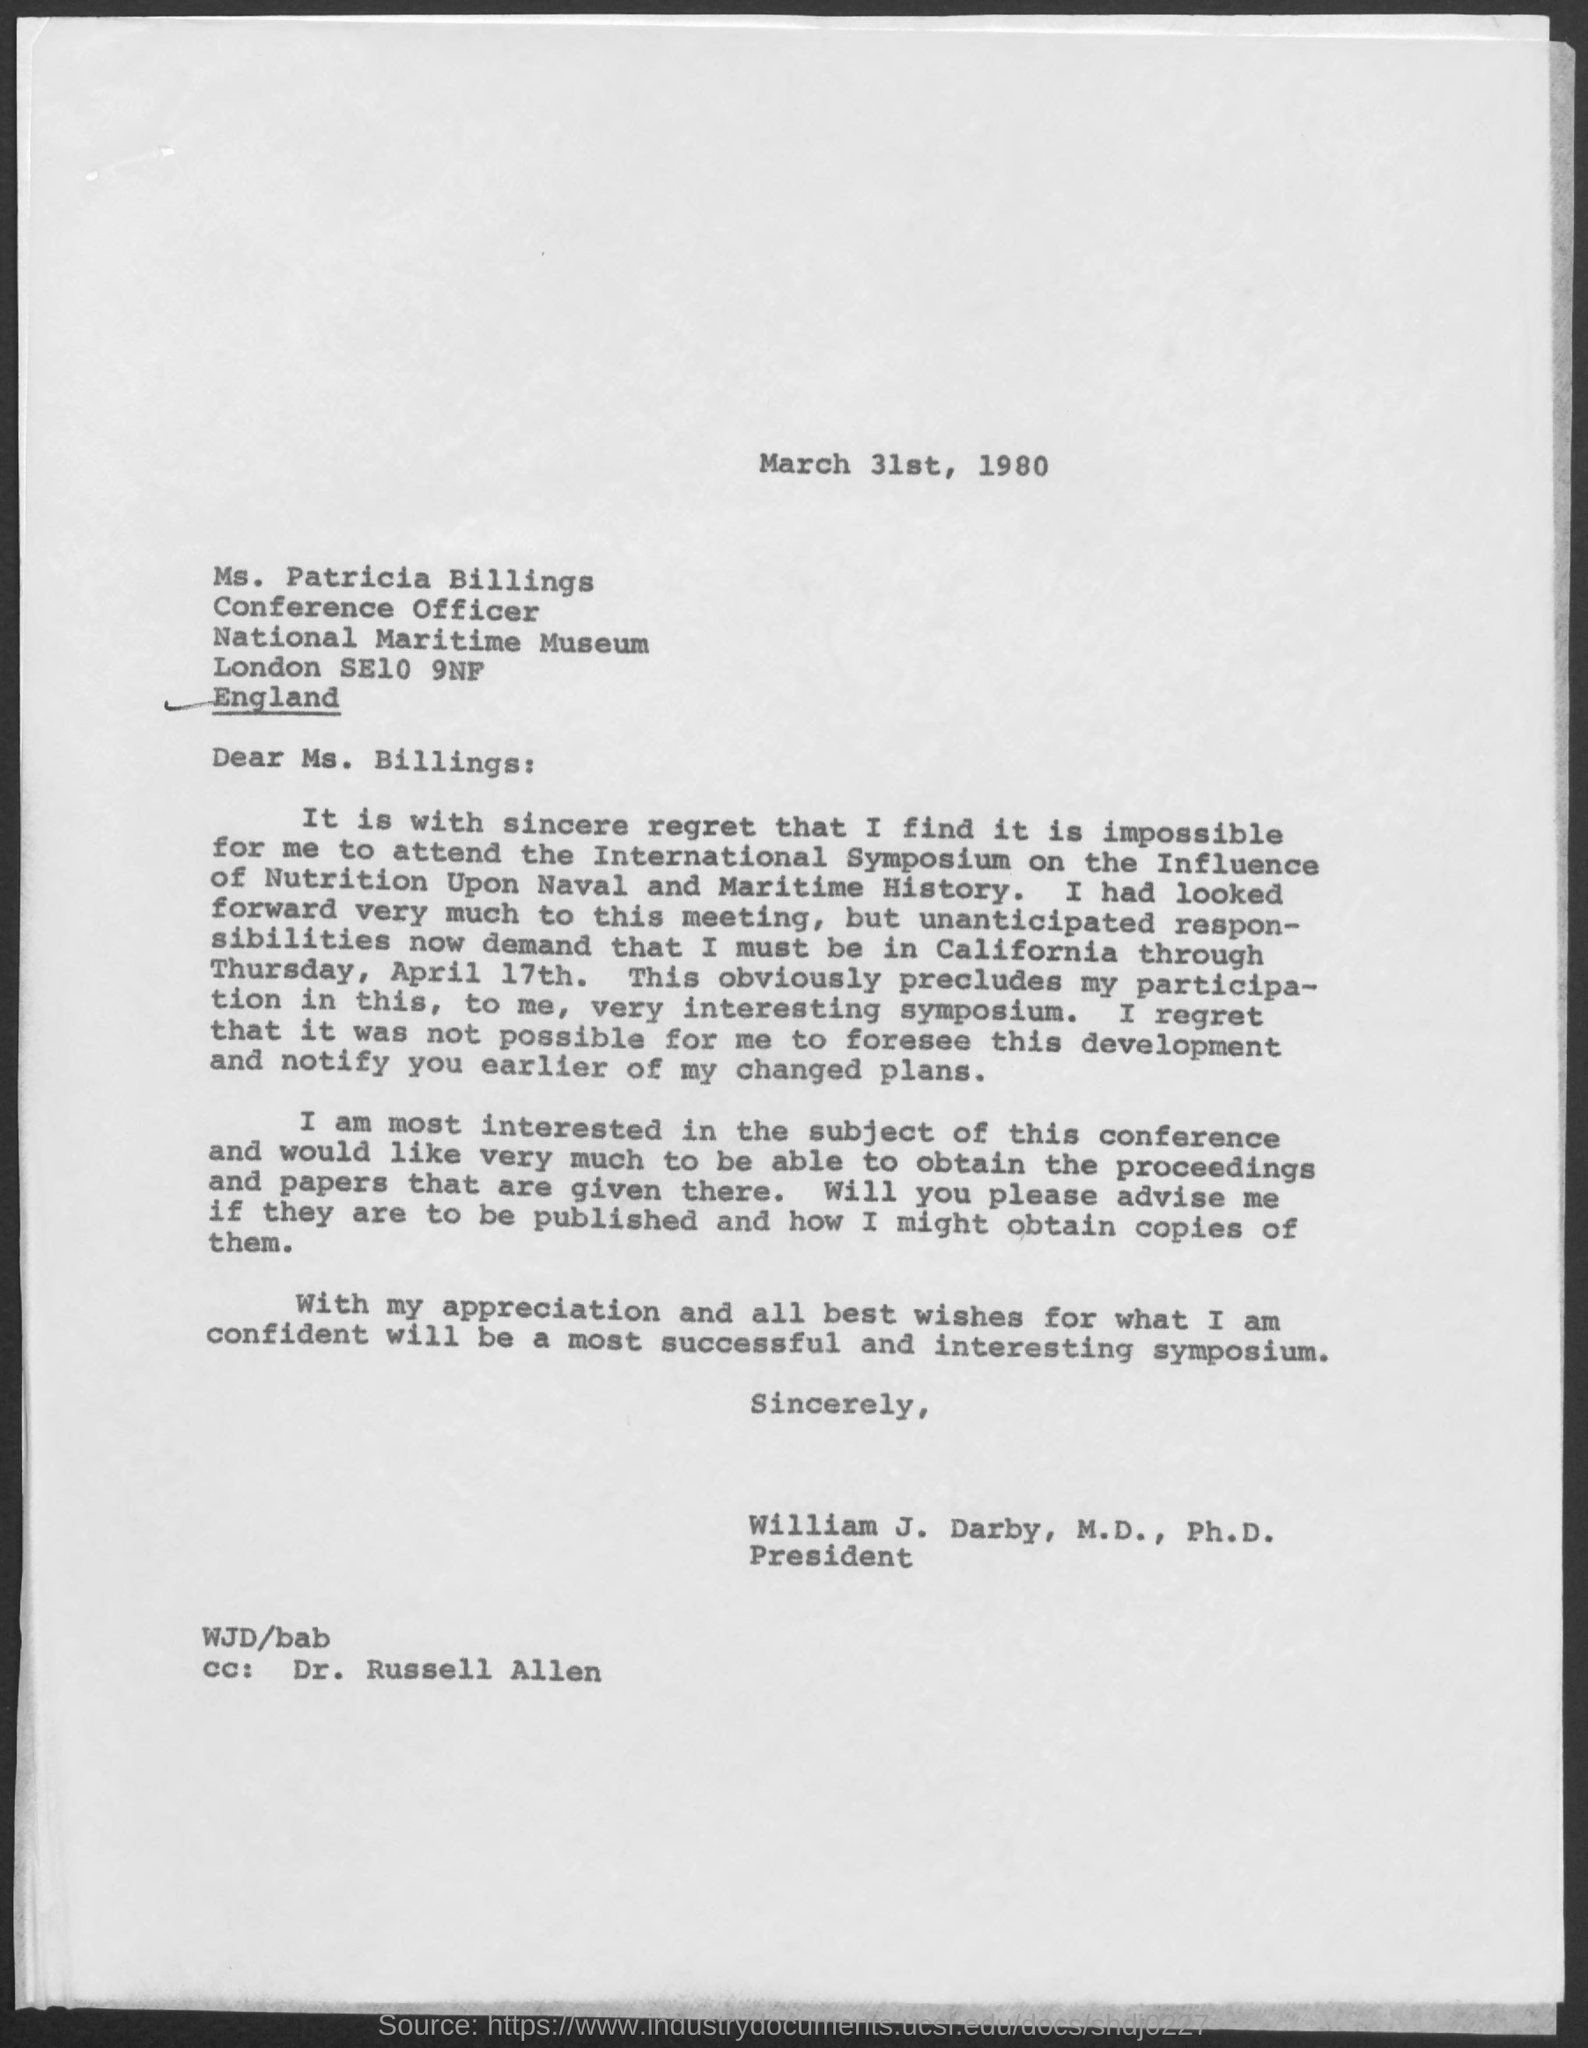What is the date mentioned in the given letter ?
Provide a succinct answer. March 31st , 1980. To whom this letter was written ?
Provide a short and direct response. Ms. Billings. What is the designation of william  j. darby ?
Your answer should be compact. President. What is the designation of ms. patricia billings as mentioned in the given letter ?
Your answer should be compact. Conference Officer. What is the name of the museum mentioned in the given letter ?
Give a very brief answer. National Maritime. 